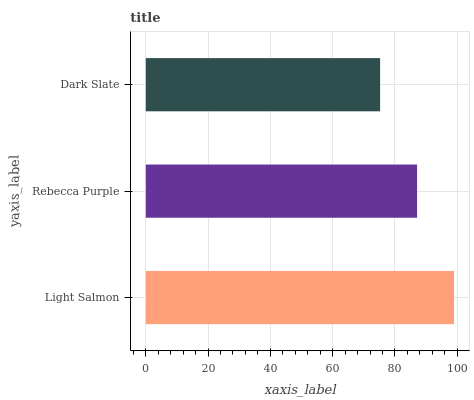Is Dark Slate the minimum?
Answer yes or no. Yes. Is Light Salmon the maximum?
Answer yes or no. Yes. Is Rebecca Purple the minimum?
Answer yes or no. No. Is Rebecca Purple the maximum?
Answer yes or no. No. Is Light Salmon greater than Rebecca Purple?
Answer yes or no. Yes. Is Rebecca Purple less than Light Salmon?
Answer yes or no. Yes. Is Rebecca Purple greater than Light Salmon?
Answer yes or no. No. Is Light Salmon less than Rebecca Purple?
Answer yes or no. No. Is Rebecca Purple the high median?
Answer yes or no. Yes. Is Rebecca Purple the low median?
Answer yes or no. Yes. Is Dark Slate the high median?
Answer yes or no. No. Is Light Salmon the low median?
Answer yes or no. No. 